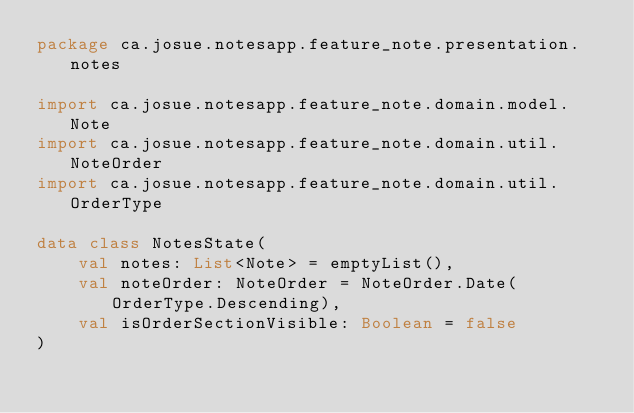Convert code to text. <code><loc_0><loc_0><loc_500><loc_500><_Kotlin_>package ca.josue.notesapp.feature_note.presentation.notes

import ca.josue.notesapp.feature_note.domain.model.Note
import ca.josue.notesapp.feature_note.domain.util.NoteOrder
import ca.josue.notesapp.feature_note.domain.util.OrderType

data class NotesState(
    val notes: List<Note> = emptyList(),
    val noteOrder: NoteOrder = NoteOrder.Date(OrderType.Descending),
    val isOrderSectionVisible: Boolean = false
)
</code> 